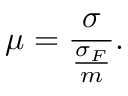Convert formula to latex. <formula><loc_0><loc_0><loc_500><loc_500>\mu = \frac { \sigma } { \frac { \sigma _ { F } } { m } } .</formula> 